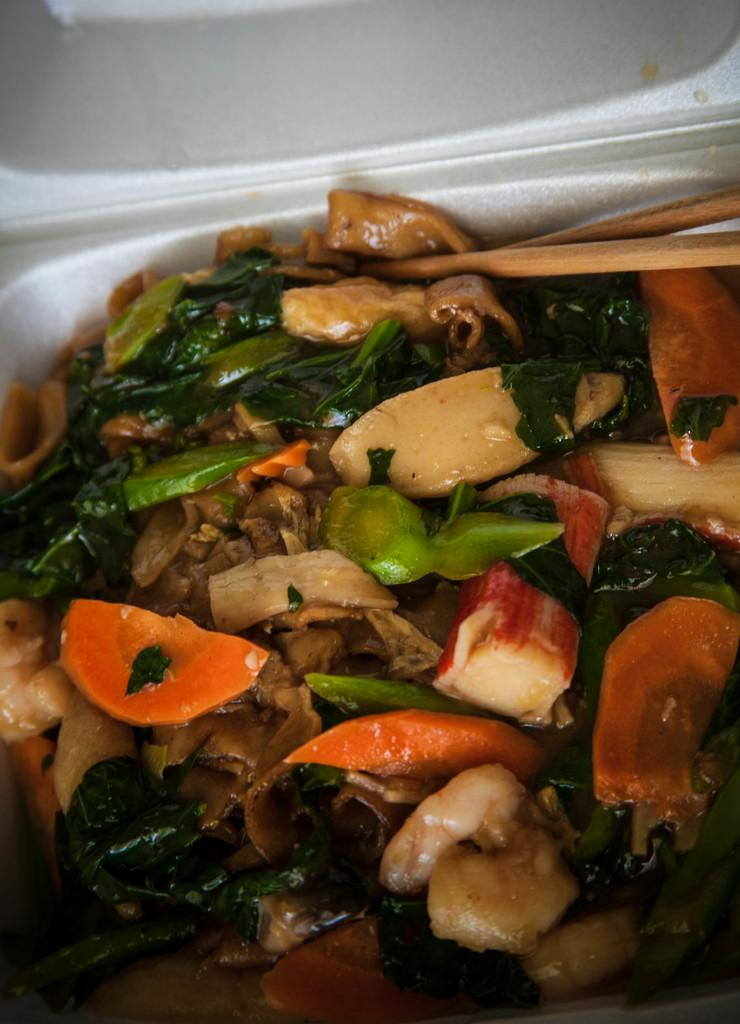What type of eatable things can be seen in the image? There are eatable things in the image, but the specific type cannot be determined from the facts provided. What other items are present in the image besides the eatable things? There are items in the image, but the specific type cannot be determined from the facts provided. What utensil is present in the image? Chopsticks are present in the image. How are the chopsticks positioned in the image? The chopsticks are placed on a white bowl in the image. What color is the cap in the image? There is a white color cap in the image. What type of sound can be heard coming from the cap in the image? There is no sound present in the image, as it is a still image and not a video or audio recording. 